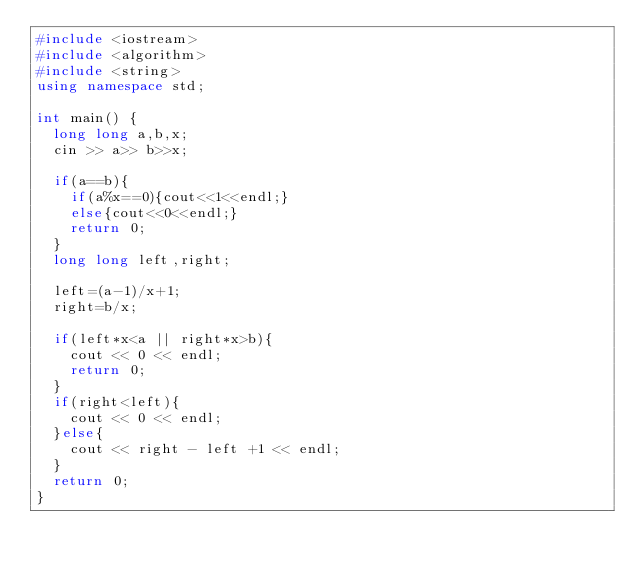Convert code to text. <code><loc_0><loc_0><loc_500><loc_500><_C++_>#include <iostream>
#include <algorithm>
#include <string>
using namespace std;

int main() {
	long long a,b,x;
	cin >> a>> b>>x;
	
	if(a==b){
		if(a%x==0){cout<<1<<endl;}
		else{cout<<0<<endl;}
		return 0;
	}
	long long left,right;
	
	left=(a-1)/x+1;
	right=b/x;
	
	if(left*x<a || right*x>b){
		cout << 0 << endl;
		return 0;
	}
	if(right<left){
		cout << 0 << endl;
	}else{
		cout << right - left +1 << endl;
	}
	return 0;
}</code> 